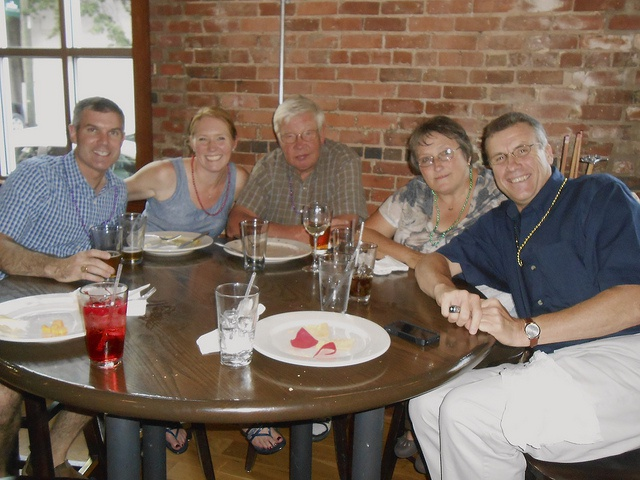Describe the objects in this image and their specific colors. I can see people in lightgray, black, and darkgray tones, dining table in lightgray, maroon, gray, and black tones, people in lightgray, darkgray, and gray tones, people in lightgray, gray, tan, and darkgray tones, and people in lightgray, gray, and brown tones in this image. 